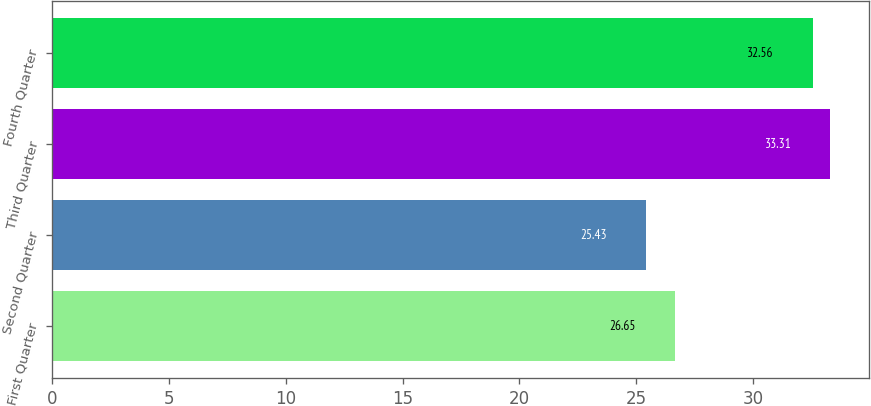<chart> <loc_0><loc_0><loc_500><loc_500><bar_chart><fcel>First Quarter<fcel>Second Quarter<fcel>Third Quarter<fcel>Fourth Quarter<nl><fcel>26.65<fcel>25.43<fcel>33.31<fcel>32.56<nl></chart> 